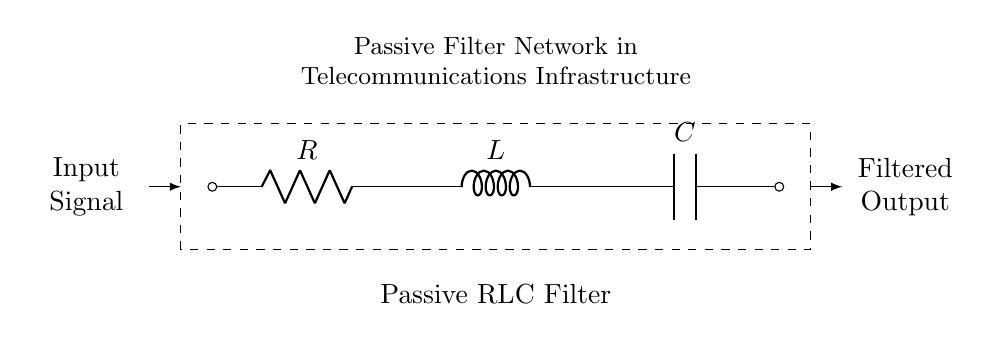What components are present in the circuit? The circuit includes a resistor, an inductor, and a capacitor, which are labeled accordingly.
Answer: Resistor, Inductor, Capacitor What type of filter does this circuit represent? This circuit represents a passive filter, as indicated by the "Passive Filter Network" label.
Answer: Passive filter What is the function of the resistor in this circuit? The resistor limits the current flow and contributes to the overall impedance of the filter.
Answer: Limit current flow How do the components in this circuit influence the signal? The resistor, inductor, and capacitor together create a frequency-dependent response that shapes the output signal by attenuating certain frequencies while allowing others to pass.
Answer: Frequency-dependent response What is the relationship between the input and output signals in this circuit? The input signal is processed by the resistor, inductor, and capacitor, resulting in a filtered output signal, meaning some frequencies are diminished or blocked.
Answer: Filtered output signal 